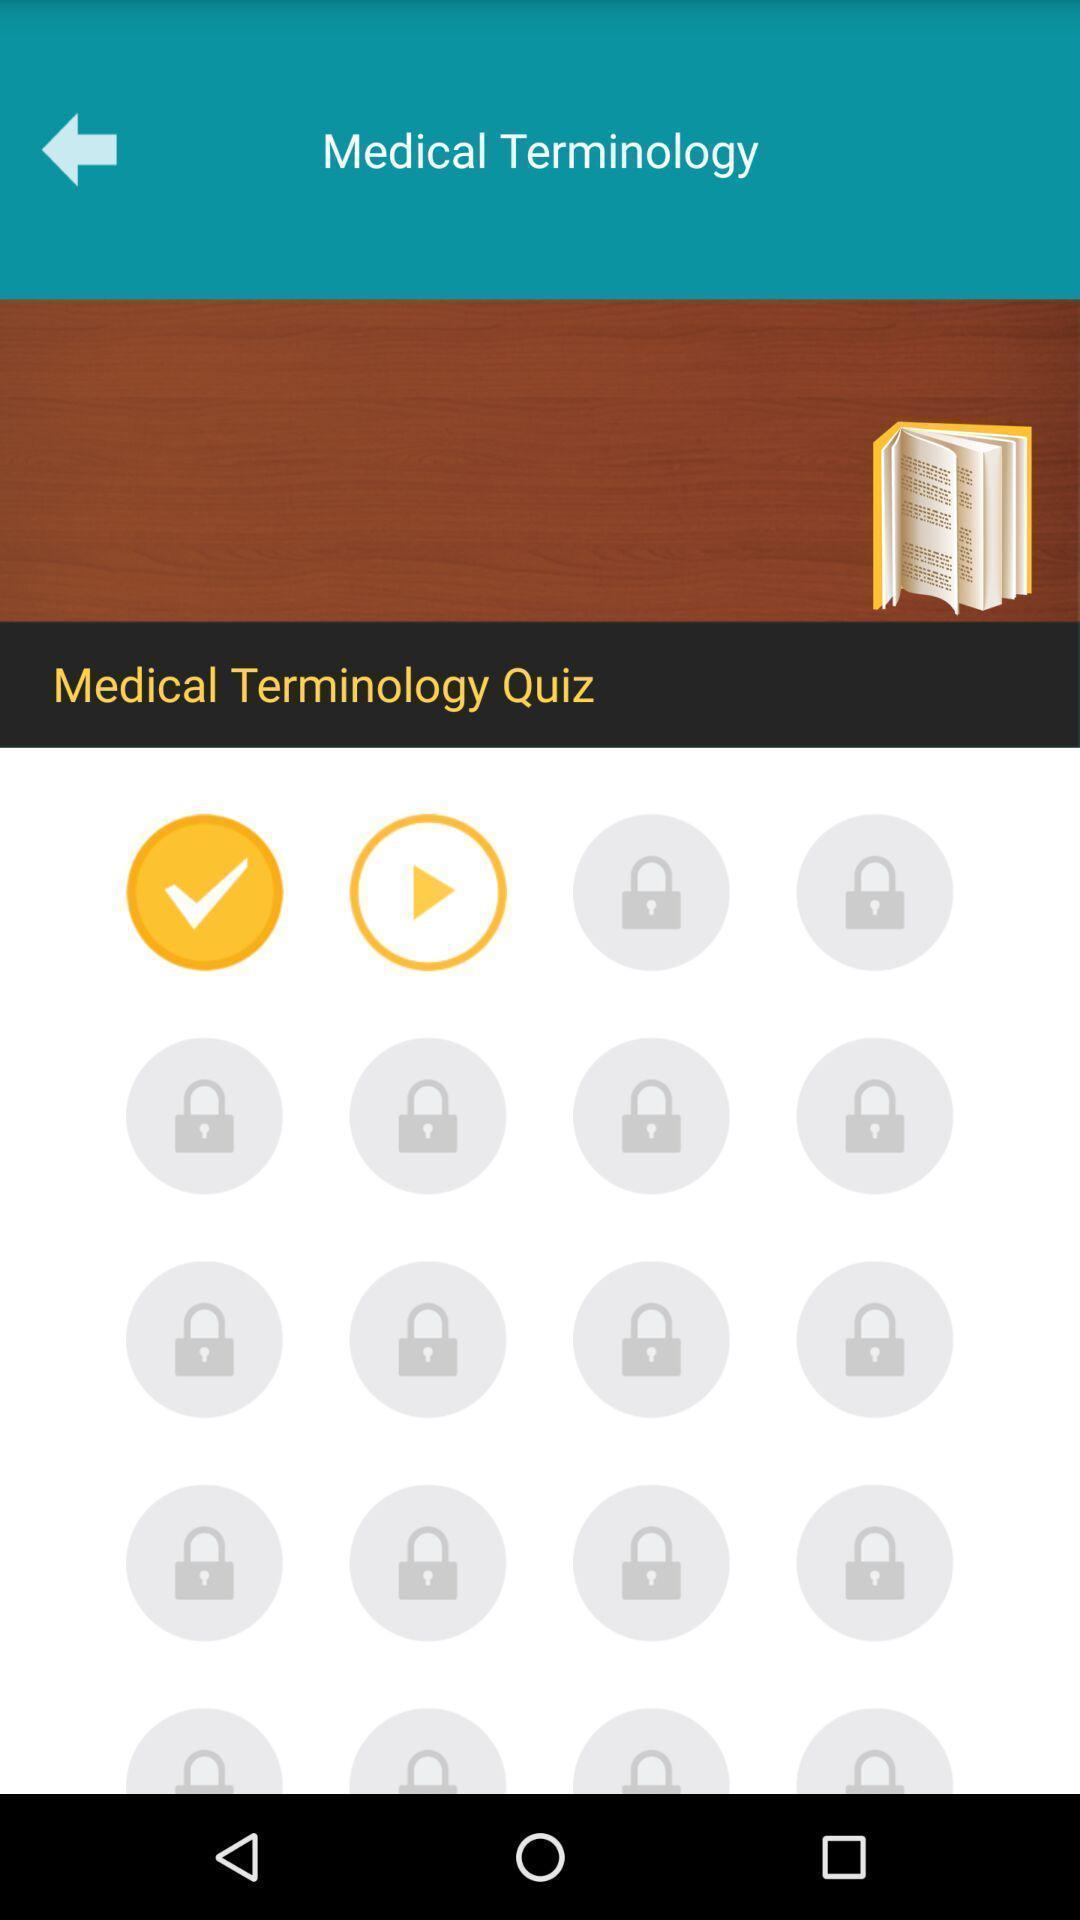Explain what's happening in this screen capture. Screen displaying multiple levels in a gaming application. 